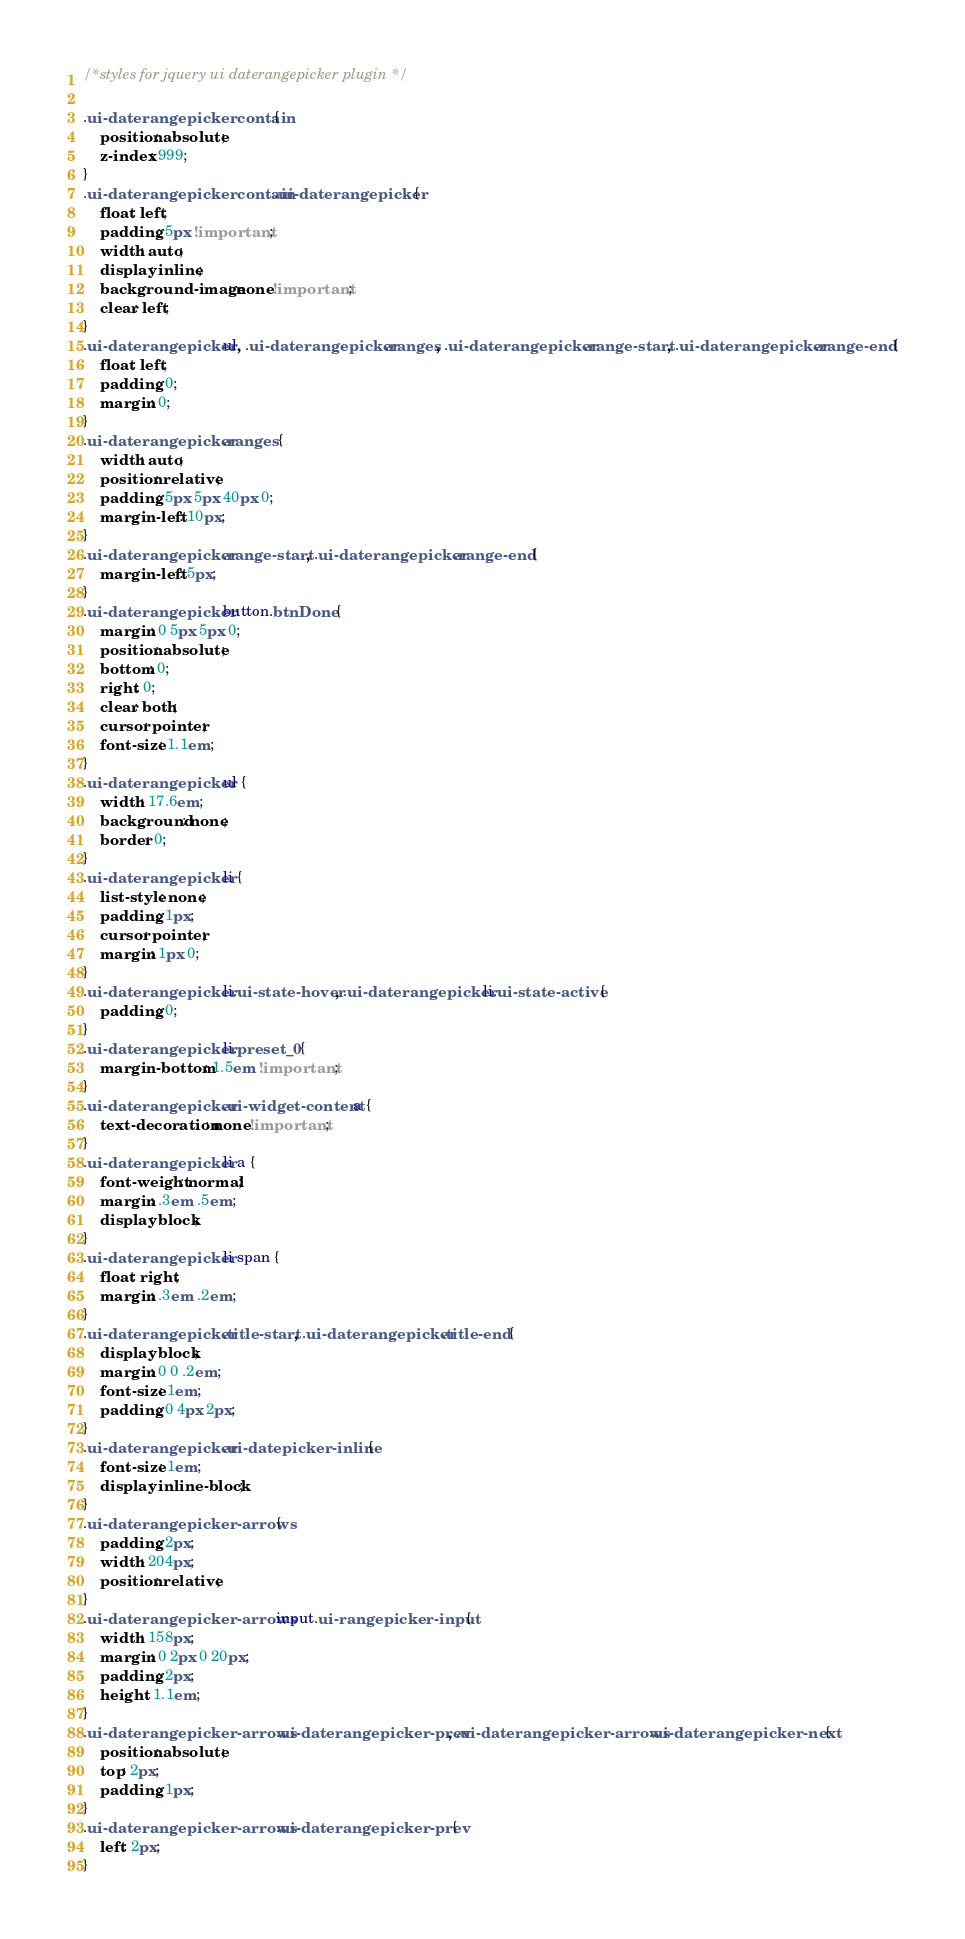<code> <loc_0><loc_0><loc_500><loc_500><_CSS_>/*styles for jquery ui daterangepicker plugin */

.ui-daterangepickercontain {
	position: absolute;
	z-index: 999;
}
.ui-daterangepickercontain .ui-daterangepicker {
	float: left;
	padding: 5px !important;
	width: auto;
	display: inline;
	background-image: none !important;
	clear: left;
}
.ui-daterangepicker ul, .ui-daterangepicker .ranges, .ui-daterangepicker .range-start, .ui-daterangepicker .range-end {
	float: left;
	padding: 0;
	margin: 0;
}
.ui-daterangepicker .ranges {
	width: auto;
	position: relative;
	padding: 5px 5px 40px 0;
	margin-left: 10px;
}
.ui-daterangepicker .range-start, .ui-daterangepicker .range-end {
	margin-left: 5px;
}
.ui-daterangepicker button.btnDone {
	margin: 0 5px 5px 0;
	position: absolute;
	bottom: 0;
	right: 0;
	clear: both;
	cursor: pointer;
	font-size: 1.1em;
}
.ui-daterangepicker ul {
	width: 17.6em;
	background: none;
	border: 0;
}
.ui-daterangepicker li {
	list-style: none;
	padding: 1px;
	cursor: pointer;
	margin: 1px 0;
}
.ui-daterangepicker li.ui-state-hover, .ui-daterangepicker li.ui-state-active {
	padding: 0;
}
.ui-daterangepicker li.preset_0 {
	margin-bottom: 1.5em !important;
}
.ui-daterangepicker .ui-widget-content a {
	text-decoration: none !important;
}
.ui-daterangepicker li a {
	font-weight: normal;
	margin: .3em .5em;
	display: block;
}
.ui-daterangepicker li span {
	float: right;
	margin: .3em .2em;
}
.ui-daterangepicker .title-start, .ui-daterangepicker .title-end {
	display: block;
	margin: 0 0 .2em;
	font-size: 1em;
	padding: 0 4px 2px;
}
.ui-daterangepicker .ui-datepicker-inline {
	font-size: 1em;
    display: inline-block;
}
.ui-daterangepicker-arrows {
	padding: 2px;
	width: 204px;
	position: relative;
}
.ui-daterangepicker-arrows input.ui-rangepicker-input {
	width: 158px;
	margin: 0 2px 0 20px;
	padding: 2px;
	height: 1.1em;
}
.ui-daterangepicker-arrows .ui-daterangepicker-prev, .ui-daterangepicker-arrows .ui-daterangepicker-next {
	position: absolute;
	top: 2px; 
	padding: 1px;
}
.ui-daterangepicker-arrows .ui-daterangepicker-prev {
	left: 2px;
}</code> 